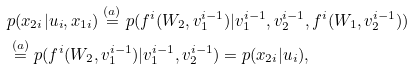Convert formula to latex. <formula><loc_0><loc_0><loc_500><loc_500>& p ( x _ { 2 i } | u _ { i } , x _ { 1 i } ) \overset { ( a ) } { = } p ( f ^ { i } ( W _ { 2 } , v _ { 1 } ^ { i - 1 } ) | v _ { 1 } ^ { i - 1 } , v _ { 2 } ^ { i - 1 } , f ^ { i } ( W _ { 1 } , v _ { 2 } ^ { i - 1 } ) ) \\ & \overset { ( a ) } { = } p ( f ^ { i } ( W _ { 2 } , v _ { 1 } ^ { i - 1 } ) | v _ { 1 } ^ { i - 1 } , v _ { 2 } ^ { i - 1 } ) = p ( x _ { 2 i } | u _ { i } ) ,</formula> 